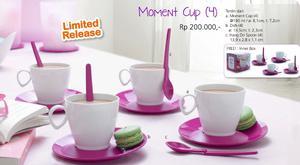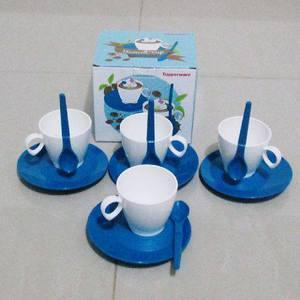The first image is the image on the left, the second image is the image on the right. Given the left and right images, does the statement "Pink transparent cups are on the left image." hold true? Answer yes or no. No. 